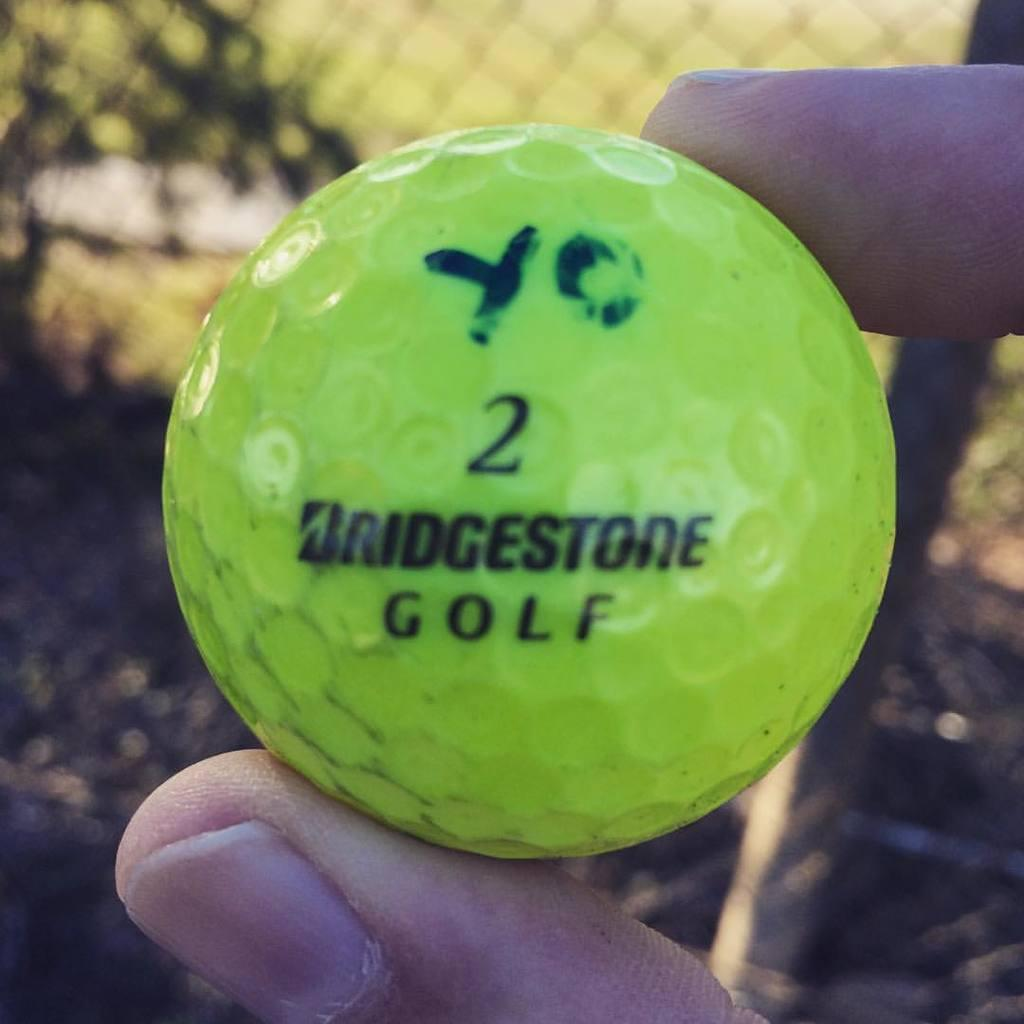What is being held by the person's fingers in the image? There is a ball being held by the person's fingers in the image. What can be seen in the background of the image? There is a mesh and a pole in the background of the image. What type of spoon is being used to hit the ball in the image? There is no spoon present in the image, and the ball is not being hit by any object. 